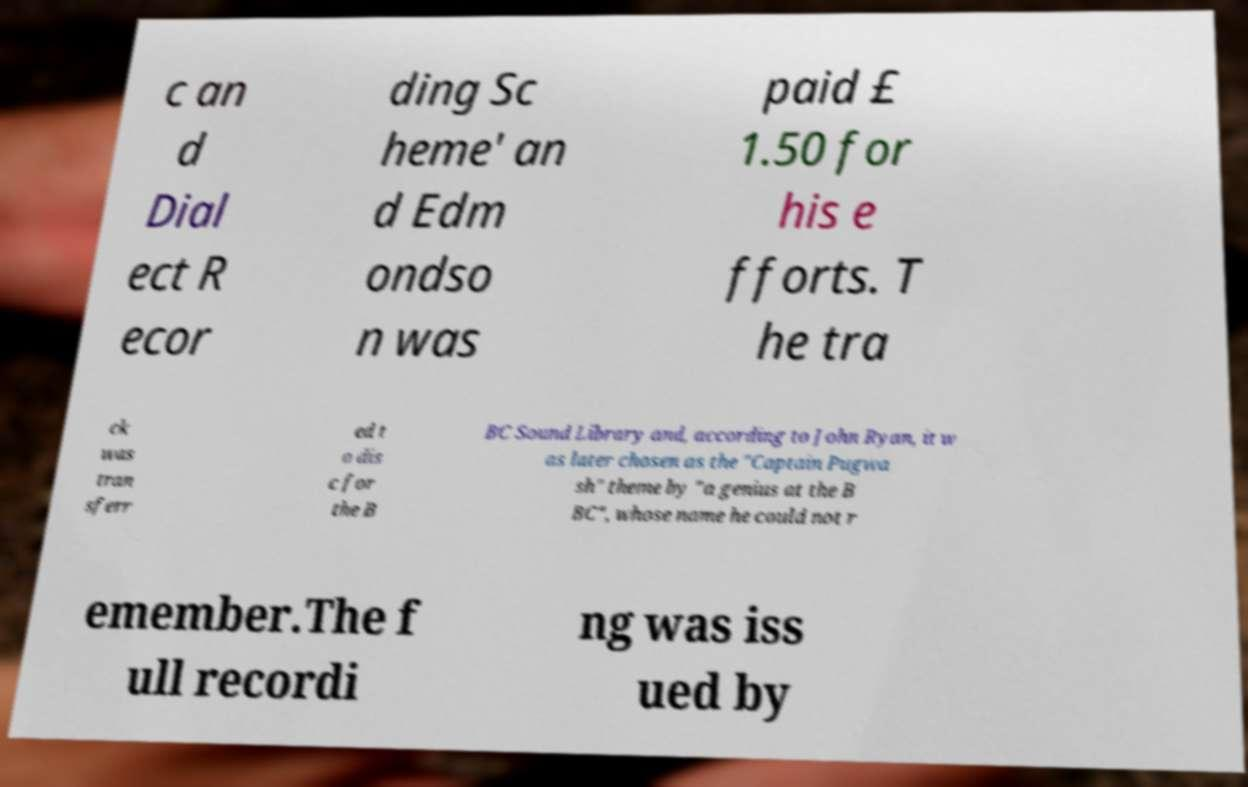I need the written content from this picture converted into text. Can you do that? c an d Dial ect R ecor ding Sc heme' an d Edm ondso n was paid £ 1.50 for his e fforts. T he tra ck was tran sferr ed t o dis c for the B BC Sound Library and, according to John Ryan, it w as later chosen as the "Captain Pugwa sh" theme by "a genius at the B BC", whose name he could not r emember.The f ull recordi ng was iss ued by 